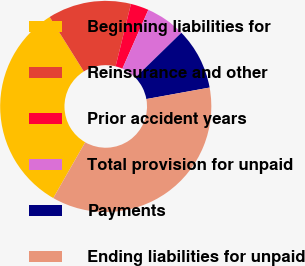Convert chart to OTSL. <chart><loc_0><loc_0><loc_500><loc_500><pie_chart><fcel>Beginning liabilities for<fcel>Reinsurance and other<fcel>Prior accident years<fcel>Total provision for unpaid<fcel>Payments<fcel>Ending liabilities for unpaid<nl><fcel>32.81%<fcel>12.75%<fcel>2.77%<fcel>6.1%<fcel>9.43%<fcel>36.14%<nl></chart> 